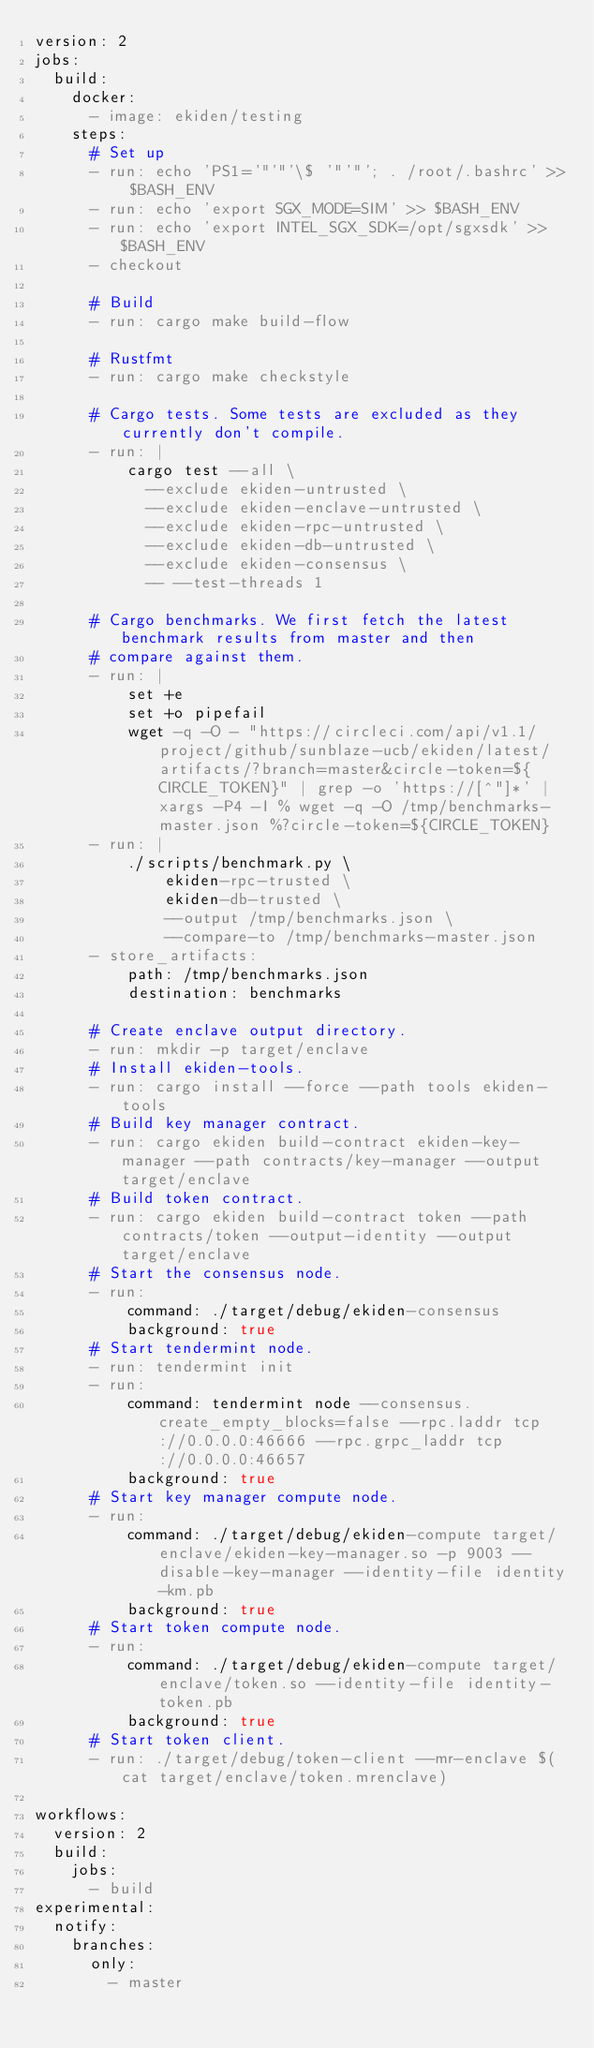<code> <loc_0><loc_0><loc_500><loc_500><_YAML_>version: 2
jobs:
  build:
    docker:
      - image: ekiden/testing
    steps:
      # Set up
      - run: echo 'PS1='"'"'\$ '"'"'; . /root/.bashrc' >> $BASH_ENV
      - run: echo 'export SGX_MODE=SIM' >> $BASH_ENV
      - run: echo 'export INTEL_SGX_SDK=/opt/sgxsdk' >> $BASH_ENV
      - checkout

      # Build
      - run: cargo make build-flow

      # Rustfmt
      - run: cargo make checkstyle

      # Cargo tests. Some tests are excluded as they currently don't compile.
      - run: |
          cargo test --all \
            --exclude ekiden-untrusted \
            --exclude ekiden-enclave-untrusted \
            --exclude ekiden-rpc-untrusted \
            --exclude ekiden-db-untrusted \
            --exclude ekiden-consensus \
            -- --test-threads 1

      # Cargo benchmarks. We first fetch the latest benchmark results from master and then
      # compare against them.
      - run: |
          set +e
          set +o pipefail
          wget -q -O - "https://circleci.com/api/v1.1/project/github/sunblaze-ucb/ekiden/latest/artifacts/?branch=master&circle-token=${CIRCLE_TOKEN}" | grep -o 'https://[^"]*' | xargs -P4 -I % wget -q -O /tmp/benchmarks-master.json %?circle-token=${CIRCLE_TOKEN}
      - run: |
          ./scripts/benchmark.py \
              ekiden-rpc-trusted \
              ekiden-db-trusted \
              --output /tmp/benchmarks.json \
              --compare-to /tmp/benchmarks-master.json
      - store_artifacts:
          path: /tmp/benchmarks.json
          destination: benchmarks

      # Create enclave output directory.
      - run: mkdir -p target/enclave
      # Install ekiden-tools.
      - run: cargo install --force --path tools ekiden-tools
      # Build key manager contract.
      - run: cargo ekiden build-contract ekiden-key-manager --path contracts/key-manager --output target/enclave
      # Build token contract.
      - run: cargo ekiden build-contract token --path contracts/token --output-identity --output target/enclave
      # Start the consensus node.
      - run:
          command: ./target/debug/ekiden-consensus
          background: true
      # Start tendermint node.
      - run: tendermint init
      - run:
          command: tendermint node --consensus.create_empty_blocks=false --rpc.laddr tcp://0.0.0.0:46666 --rpc.grpc_laddr tcp://0.0.0.0:46657
          background: true
      # Start key manager compute node.
      - run:
          command: ./target/debug/ekiden-compute target/enclave/ekiden-key-manager.so -p 9003 --disable-key-manager --identity-file identity-km.pb
          background: true
      # Start token compute node.
      - run:
          command: ./target/debug/ekiden-compute target/enclave/token.so --identity-file identity-token.pb
          background: true
      # Start token client.
      - run: ./target/debug/token-client --mr-enclave $(cat target/enclave/token.mrenclave)

workflows:
  version: 2
  build:
    jobs:
      - build
experimental:
  notify:
    branches:
      only:
        - master
</code> 